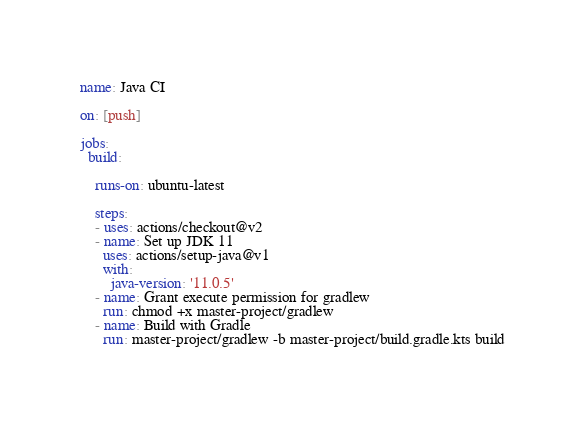<code> <loc_0><loc_0><loc_500><loc_500><_YAML_>name: Java CI

on: [push]

jobs:
  build:

    runs-on: ubuntu-latest

    steps:
    - uses: actions/checkout@v2
    - name: Set up JDK 11
      uses: actions/setup-java@v1
      with:
        java-version: '11.0.5'
    - name: Grant execute permission for gradlew
      run: chmod +x master-project/gradlew
    - name: Build with Gradle
      run: master-project/gradlew -b master-project/build.gradle.kts build
</code> 